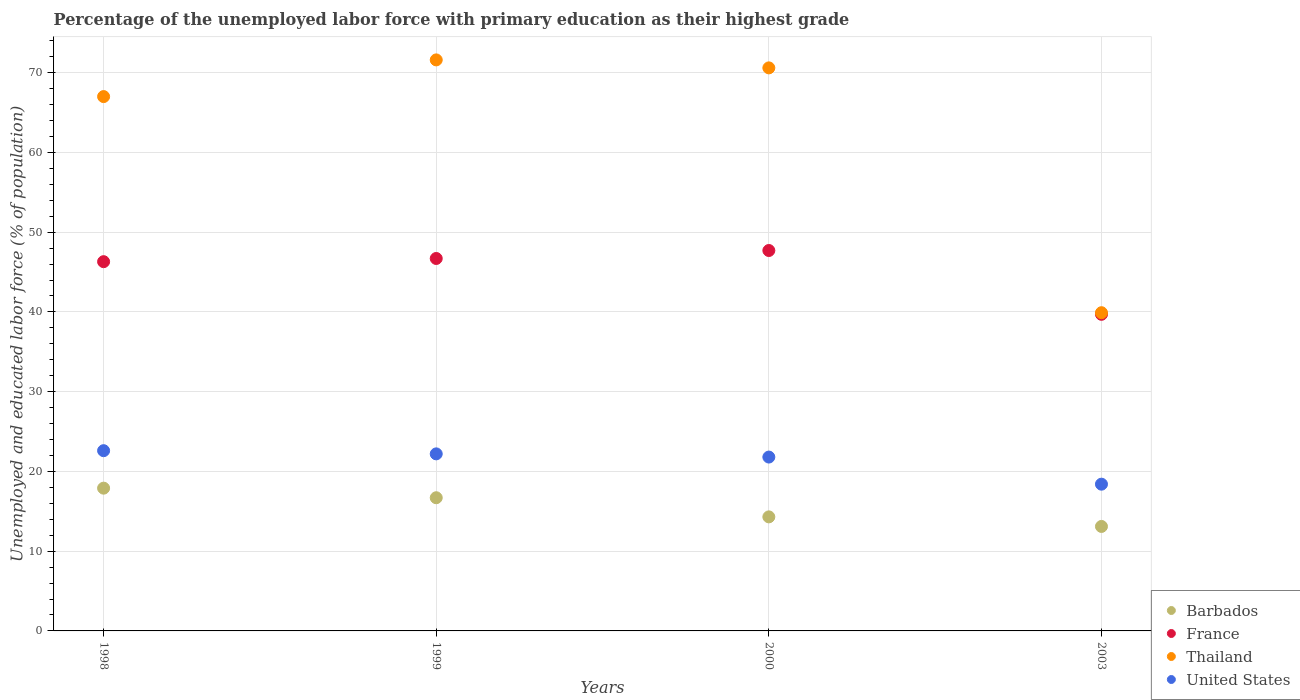How many different coloured dotlines are there?
Make the answer very short. 4. Is the number of dotlines equal to the number of legend labels?
Give a very brief answer. Yes. What is the percentage of the unemployed labor force with primary education in Thailand in 1999?
Provide a short and direct response. 71.6. Across all years, what is the maximum percentage of the unemployed labor force with primary education in Thailand?
Offer a terse response. 71.6. Across all years, what is the minimum percentage of the unemployed labor force with primary education in Thailand?
Your answer should be very brief. 39.9. In which year was the percentage of the unemployed labor force with primary education in United States maximum?
Provide a succinct answer. 1998. In which year was the percentage of the unemployed labor force with primary education in Barbados minimum?
Offer a very short reply. 2003. What is the difference between the percentage of the unemployed labor force with primary education in Thailand in 1998 and that in 1999?
Offer a terse response. -4.6. What is the difference between the percentage of the unemployed labor force with primary education in Barbados in 1998 and the percentage of the unemployed labor force with primary education in France in 1999?
Provide a short and direct response. -28.8. What is the average percentage of the unemployed labor force with primary education in France per year?
Make the answer very short. 45.1. In the year 1999, what is the difference between the percentage of the unemployed labor force with primary education in Barbados and percentage of the unemployed labor force with primary education in France?
Offer a terse response. -30. In how many years, is the percentage of the unemployed labor force with primary education in France greater than 72 %?
Offer a terse response. 0. What is the ratio of the percentage of the unemployed labor force with primary education in United States in 1998 to that in 2000?
Your answer should be compact. 1.04. What is the difference between the highest and the second highest percentage of the unemployed labor force with primary education in Thailand?
Make the answer very short. 1. What is the difference between the highest and the lowest percentage of the unemployed labor force with primary education in Thailand?
Offer a terse response. 31.7. In how many years, is the percentage of the unemployed labor force with primary education in France greater than the average percentage of the unemployed labor force with primary education in France taken over all years?
Ensure brevity in your answer.  3. Is it the case that in every year, the sum of the percentage of the unemployed labor force with primary education in France and percentage of the unemployed labor force with primary education in United States  is greater than the percentage of the unemployed labor force with primary education in Thailand?
Provide a succinct answer. No. Is the percentage of the unemployed labor force with primary education in United States strictly less than the percentage of the unemployed labor force with primary education in Thailand over the years?
Give a very brief answer. Yes. How many dotlines are there?
Keep it short and to the point. 4. What is the difference between two consecutive major ticks on the Y-axis?
Provide a succinct answer. 10. Are the values on the major ticks of Y-axis written in scientific E-notation?
Give a very brief answer. No. Does the graph contain any zero values?
Your response must be concise. No. Does the graph contain grids?
Make the answer very short. Yes. What is the title of the graph?
Provide a short and direct response. Percentage of the unemployed labor force with primary education as their highest grade. What is the label or title of the Y-axis?
Your answer should be compact. Unemployed and educated labor force (% of population). What is the Unemployed and educated labor force (% of population) in Barbados in 1998?
Provide a succinct answer. 17.9. What is the Unemployed and educated labor force (% of population) of France in 1998?
Provide a succinct answer. 46.3. What is the Unemployed and educated labor force (% of population) of United States in 1998?
Offer a terse response. 22.6. What is the Unemployed and educated labor force (% of population) in Barbados in 1999?
Provide a short and direct response. 16.7. What is the Unemployed and educated labor force (% of population) of France in 1999?
Provide a short and direct response. 46.7. What is the Unemployed and educated labor force (% of population) of Thailand in 1999?
Ensure brevity in your answer.  71.6. What is the Unemployed and educated labor force (% of population) of United States in 1999?
Your answer should be compact. 22.2. What is the Unemployed and educated labor force (% of population) of Barbados in 2000?
Your answer should be compact. 14.3. What is the Unemployed and educated labor force (% of population) in France in 2000?
Your response must be concise. 47.7. What is the Unemployed and educated labor force (% of population) of Thailand in 2000?
Offer a very short reply. 70.6. What is the Unemployed and educated labor force (% of population) of United States in 2000?
Provide a succinct answer. 21.8. What is the Unemployed and educated labor force (% of population) in Barbados in 2003?
Provide a succinct answer. 13.1. What is the Unemployed and educated labor force (% of population) of France in 2003?
Keep it short and to the point. 39.7. What is the Unemployed and educated labor force (% of population) of Thailand in 2003?
Offer a very short reply. 39.9. What is the Unemployed and educated labor force (% of population) in United States in 2003?
Your answer should be very brief. 18.4. Across all years, what is the maximum Unemployed and educated labor force (% of population) in Barbados?
Give a very brief answer. 17.9. Across all years, what is the maximum Unemployed and educated labor force (% of population) of France?
Provide a short and direct response. 47.7. Across all years, what is the maximum Unemployed and educated labor force (% of population) of Thailand?
Provide a short and direct response. 71.6. Across all years, what is the maximum Unemployed and educated labor force (% of population) of United States?
Your answer should be very brief. 22.6. Across all years, what is the minimum Unemployed and educated labor force (% of population) in Barbados?
Make the answer very short. 13.1. Across all years, what is the minimum Unemployed and educated labor force (% of population) of France?
Keep it short and to the point. 39.7. Across all years, what is the minimum Unemployed and educated labor force (% of population) of Thailand?
Make the answer very short. 39.9. Across all years, what is the minimum Unemployed and educated labor force (% of population) in United States?
Make the answer very short. 18.4. What is the total Unemployed and educated labor force (% of population) of Barbados in the graph?
Give a very brief answer. 62. What is the total Unemployed and educated labor force (% of population) of France in the graph?
Offer a terse response. 180.4. What is the total Unemployed and educated labor force (% of population) in Thailand in the graph?
Provide a succinct answer. 249.1. What is the difference between the Unemployed and educated labor force (% of population) in Thailand in 1998 and that in 1999?
Make the answer very short. -4.6. What is the difference between the Unemployed and educated labor force (% of population) of Barbados in 1998 and that in 2000?
Ensure brevity in your answer.  3.6. What is the difference between the Unemployed and educated labor force (% of population) in Barbados in 1998 and that in 2003?
Give a very brief answer. 4.8. What is the difference between the Unemployed and educated labor force (% of population) in Thailand in 1998 and that in 2003?
Offer a terse response. 27.1. What is the difference between the Unemployed and educated labor force (% of population) in United States in 1998 and that in 2003?
Make the answer very short. 4.2. What is the difference between the Unemployed and educated labor force (% of population) of Barbados in 1999 and that in 2000?
Offer a very short reply. 2.4. What is the difference between the Unemployed and educated labor force (% of population) of United States in 1999 and that in 2000?
Make the answer very short. 0.4. What is the difference between the Unemployed and educated labor force (% of population) of Thailand in 1999 and that in 2003?
Ensure brevity in your answer.  31.7. What is the difference between the Unemployed and educated labor force (% of population) of Thailand in 2000 and that in 2003?
Provide a short and direct response. 30.7. What is the difference between the Unemployed and educated labor force (% of population) in United States in 2000 and that in 2003?
Offer a terse response. 3.4. What is the difference between the Unemployed and educated labor force (% of population) in Barbados in 1998 and the Unemployed and educated labor force (% of population) in France in 1999?
Your answer should be compact. -28.8. What is the difference between the Unemployed and educated labor force (% of population) in Barbados in 1998 and the Unemployed and educated labor force (% of population) in Thailand in 1999?
Offer a very short reply. -53.7. What is the difference between the Unemployed and educated labor force (% of population) of France in 1998 and the Unemployed and educated labor force (% of population) of Thailand in 1999?
Provide a short and direct response. -25.3. What is the difference between the Unemployed and educated labor force (% of population) of France in 1998 and the Unemployed and educated labor force (% of population) of United States in 1999?
Provide a succinct answer. 24.1. What is the difference between the Unemployed and educated labor force (% of population) in Thailand in 1998 and the Unemployed and educated labor force (% of population) in United States in 1999?
Offer a terse response. 44.8. What is the difference between the Unemployed and educated labor force (% of population) of Barbados in 1998 and the Unemployed and educated labor force (% of population) of France in 2000?
Provide a short and direct response. -29.8. What is the difference between the Unemployed and educated labor force (% of population) of Barbados in 1998 and the Unemployed and educated labor force (% of population) of Thailand in 2000?
Ensure brevity in your answer.  -52.7. What is the difference between the Unemployed and educated labor force (% of population) of Barbados in 1998 and the Unemployed and educated labor force (% of population) of United States in 2000?
Make the answer very short. -3.9. What is the difference between the Unemployed and educated labor force (% of population) in France in 1998 and the Unemployed and educated labor force (% of population) in Thailand in 2000?
Your response must be concise. -24.3. What is the difference between the Unemployed and educated labor force (% of population) in Thailand in 1998 and the Unemployed and educated labor force (% of population) in United States in 2000?
Provide a short and direct response. 45.2. What is the difference between the Unemployed and educated labor force (% of population) of Barbados in 1998 and the Unemployed and educated labor force (% of population) of France in 2003?
Ensure brevity in your answer.  -21.8. What is the difference between the Unemployed and educated labor force (% of population) of Barbados in 1998 and the Unemployed and educated labor force (% of population) of Thailand in 2003?
Offer a very short reply. -22. What is the difference between the Unemployed and educated labor force (% of population) in Barbados in 1998 and the Unemployed and educated labor force (% of population) in United States in 2003?
Keep it short and to the point. -0.5. What is the difference between the Unemployed and educated labor force (% of population) in France in 1998 and the Unemployed and educated labor force (% of population) in Thailand in 2003?
Give a very brief answer. 6.4. What is the difference between the Unemployed and educated labor force (% of population) of France in 1998 and the Unemployed and educated labor force (% of population) of United States in 2003?
Make the answer very short. 27.9. What is the difference between the Unemployed and educated labor force (% of population) of Thailand in 1998 and the Unemployed and educated labor force (% of population) of United States in 2003?
Your answer should be compact. 48.6. What is the difference between the Unemployed and educated labor force (% of population) in Barbados in 1999 and the Unemployed and educated labor force (% of population) in France in 2000?
Your response must be concise. -31. What is the difference between the Unemployed and educated labor force (% of population) of Barbados in 1999 and the Unemployed and educated labor force (% of population) of Thailand in 2000?
Make the answer very short. -53.9. What is the difference between the Unemployed and educated labor force (% of population) of France in 1999 and the Unemployed and educated labor force (% of population) of Thailand in 2000?
Your answer should be compact. -23.9. What is the difference between the Unemployed and educated labor force (% of population) in France in 1999 and the Unemployed and educated labor force (% of population) in United States in 2000?
Offer a terse response. 24.9. What is the difference between the Unemployed and educated labor force (% of population) in Thailand in 1999 and the Unemployed and educated labor force (% of population) in United States in 2000?
Keep it short and to the point. 49.8. What is the difference between the Unemployed and educated labor force (% of population) of Barbados in 1999 and the Unemployed and educated labor force (% of population) of France in 2003?
Your response must be concise. -23. What is the difference between the Unemployed and educated labor force (% of population) of Barbados in 1999 and the Unemployed and educated labor force (% of population) of Thailand in 2003?
Your response must be concise. -23.2. What is the difference between the Unemployed and educated labor force (% of population) in Barbados in 1999 and the Unemployed and educated labor force (% of population) in United States in 2003?
Your answer should be compact. -1.7. What is the difference between the Unemployed and educated labor force (% of population) of France in 1999 and the Unemployed and educated labor force (% of population) of Thailand in 2003?
Your response must be concise. 6.8. What is the difference between the Unemployed and educated labor force (% of population) of France in 1999 and the Unemployed and educated labor force (% of population) of United States in 2003?
Your answer should be very brief. 28.3. What is the difference between the Unemployed and educated labor force (% of population) of Thailand in 1999 and the Unemployed and educated labor force (% of population) of United States in 2003?
Your answer should be very brief. 53.2. What is the difference between the Unemployed and educated labor force (% of population) in Barbados in 2000 and the Unemployed and educated labor force (% of population) in France in 2003?
Provide a short and direct response. -25.4. What is the difference between the Unemployed and educated labor force (% of population) of Barbados in 2000 and the Unemployed and educated labor force (% of population) of Thailand in 2003?
Your answer should be very brief. -25.6. What is the difference between the Unemployed and educated labor force (% of population) of France in 2000 and the Unemployed and educated labor force (% of population) of United States in 2003?
Give a very brief answer. 29.3. What is the difference between the Unemployed and educated labor force (% of population) of Thailand in 2000 and the Unemployed and educated labor force (% of population) of United States in 2003?
Keep it short and to the point. 52.2. What is the average Unemployed and educated labor force (% of population) of Barbados per year?
Make the answer very short. 15.5. What is the average Unemployed and educated labor force (% of population) in France per year?
Offer a terse response. 45.1. What is the average Unemployed and educated labor force (% of population) of Thailand per year?
Your answer should be very brief. 62.27. What is the average Unemployed and educated labor force (% of population) in United States per year?
Your answer should be very brief. 21.25. In the year 1998, what is the difference between the Unemployed and educated labor force (% of population) of Barbados and Unemployed and educated labor force (% of population) of France?
Ensure brevity in your answer.  -28.4. In the year 1998, what is the difference between the Unemployed and educated labor force (% of population) in Barbados and Unemployed and educated labor force (% of population) in Thailand?
Make the answer very short. -49.1. In the year 1998, what is the difference between the Unemployed and educated labor force (% of population) of France and Unemployed and educated labor force (% of population) of Thailand?
Make the answer very short. -20.7. In the year 1998, what is the difference between the Unemployed and educated labor force (% of population) in France and Unemployed and educated labor force (% of population) in United States?
Make the answer very short. 23.7. In the year 1998, what is the difference between the Unemployed and educated labor force (% of population) of Thailand and Unemployed and educated labor force (% of population) of United States?
Ensure brevity in your answer.  44.4. In the year 1999, what is the difference between the Unemployed and educated labor force (% of population) of Barbados and Unemployed and educated labor force (% of population) of Thailand?
Provide a succinct answer. -54.9. In the year 1999, what is the difference between the Unemployed and educated labor force (% of population) of Barbados and Unemployed and educated labor force (% of population) of United States?
Offer a terse response. -5.5. In the year 1999, what is the difference between the Unemployed and educated labor force (% of population) of France and Unemployed and educated labor force (% of population) of Thailand?
Ensure brevity in your answer.  -24.9. In the year 1999, what is the difference between the Unemployed and educated labor force (% of population) in France and Unemployed and educated labor force (% of population) in United States?
Your answer should be compact. 24.5. In the year 1999, what is the difference between the Unemployed and educated labor force (% of population) in Thailand and Unemployed and educated labor force (% of population) in United States?
Offer a very short reply. 49.4. In the year 2000, what is the difference between the Unemployed and educated labor force (% of population) in Barbados and Unemployed and educated labor force (% of population) in France?
Give a very brief answer. -33.4. In the year 2000, what is the difference between the Unemployed and educated labor force (% of population) in Barbados and Unemployed and educated labor force (% of population) in Thailand?
Offer a terse response. -56.3. In the year 2000, what is the difference between the Unemployed and educated labor force (% of population) of France and Unemployed and educated labor force (% of population) of Thailand?
Offer a very short reply. -22.9. In the year 2000, what is the difference between the Unemployed and educated labor force (% of population) in France and Unemployed and educated labor force (% of population) in United States?
Keep it short and to the point. 25.9. In the year 2000, what is the difference between the Unemployed and educated labor force (% of population) of Thailand and Unemployed and educated labor force (% of population) of United States?
Provide a succinct answer. 48.8. In the year 2003, what is the difference between the Unemployed and educated labor force (% of population) of Barbados and Unemployed and educated labor force (% of population) of France?
Make the answer very short. -26.6. In the year 2003, what is the difference between the Unemployed and educated labor force (% of population) in Barbados and Unemployed and educated labor force (% of population) in Thailand?
Your response must be concise. -26.8. In the year 2003, what is the difference between the Unemployed and educated labor force (% of population) of France and Unemployed and educated labor force (% of population) of United States?
Make the answer very short. 21.3. In the year 2003, what is the difference between the Unemployed and educated labor force (% of population) in Thailand and Unemployed and educated labor force (% of population) in United States?
Ensure brevity in your answer.  21.5. What is the ratio of the Unemployed and educated labor force (% of population) of Barbados in 1998 to that in 1999?
Give a very brief answer. 1.07. What is the ratio of the Unemployed and educated labor force (% of population) of France in 1998 to that in 1999?
Ensure brevity in your answer.  0.99. What is the ratio of the Unemployed and educated labor force (% of population) in Thailand in 1998 to that in 1999?
Your answer should be compact. 0.94. What is the ratio of the Unemployed and educated labor force (% of population) of United States in 1998 to that in 1999?
Provide a succinct answer. 1.02. What is the ratio of the Unemployed and educated labor force (% of population) of Barbados in 1998 to that in 2000?
Ensure brevity in your answer.  1.25. What is the ratio of the Unemployed and educated labor force (% of population) of France in 1998 to that in 2000?
Your answer should be compact. 0.97. What is the ratio of the Unemployed and educated labor force (% of population) of Thailand in 1998 to that in 2000?
Your answer should be compact. 0.95. What is the ratio of the Unemployed and educated labor force (% of population) in United States in 1998 to that in 2000?
Provide a succinct answer. 1.04. What is the ratio of the Unemployed and educated labor force (% of population) of Barbados in 1998 to that in 2003?
Your answer should be very brief. 1.37. What is the ratio of the Unemployed and educated labor force (% of population) in France in 1998 to that in 2003?
Offer a very short reply. 1.17. What is the ratio of the Unemployed and educated labor force (% of population) of Thailand in 1998 to that in 2003?
Offer a very short reply. 1.68. What is the ratio of the Unemployed and educated labor force (% of population) in United States in 1998 to that in 2003?
Keep it short and to the point. 1.23. What is the ratio of the Unemployed and educated labor force (% of population) of Barbados in 1999 to that in 2000?
Provide a short and direct response. 1.17. What is the ratio of the Unemployed and educated labor force (% of population) in France in 1999 to that in 2000?
Your answer should be compact. 0.98. What is the ratio of the Unemployed and educated labor force (% of population) of Thailand in 1999 to that in 2000?
Keep it short and to the point. 1.01. What is the ratio of the Unemployed and educated labor force (% of population) in United States in 1999 to that in 2000?
Offer a terse response. 1.02. What is the ratio of the Unemployed and educated labor force (% of population) in Barbados in 1999 to that in 2003?
Your answer should be very brief. 1.27. What is the ratio of the Unemployed and educated labor force (% of population) of France in 1999 to that in 2003?
Make the answer very short. 1.18. What is the ratio of the Unemployed and educated labor force (% of population) of Thailand in 1999 to that in 2003?
Offer a very short reply. 1.79. What is the ratio of the Unemployed and educated labor force (% of population) of United States in 1999 to that in 2003?
Offer a terse response. 1.21. What is the ratio of the Unemployed and educated labor force (% of population) of Barbados in 2000 to that in 2003?
Offer a very short reply. 1.09. What is the ratio of the Unemployed and educated labor force (% of population) in France in 2000 to that in 2003?
Your answer should be compact. 1.2. What is the ratio of the Unemployed and educated labor force (% of population) of Thailand in 2000 to that in 2003?
Make the answer very short. 1.77. What is the ratio of the Unemployed and educated labor force (% of population) of United States in 2000 to that in 2003?
Your response must be concise. 1.18. What is the difference between the highest and the second highest Unemployed and educated labor force (% of population) of France?
Your response must be concise. 1. What is the difference between the highest and the second highest Unemployed and educated labor force (% of population) of Thailand?
Provide a succinct answer. 1. What is the difference between the highest and the lowest Unemployed and educated labor force (% of population) of Thailand?
Make the answer very short. 31.7. 